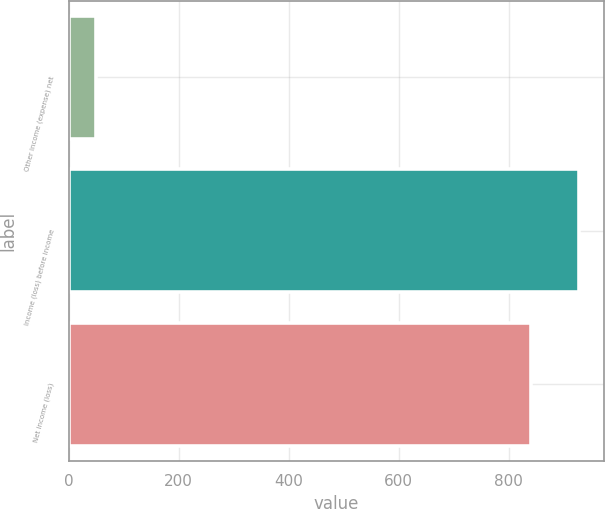Convert chart to OTSL. <chart><loc_0><loc_0><loc_500><loc_500><bar_chart><fcel>Other income (expense) net<fcel>Income (loss) before income<fcel>Net income (loss)<nl><fcel>50<fcel>927.4<fcel>840<nl></chart> 